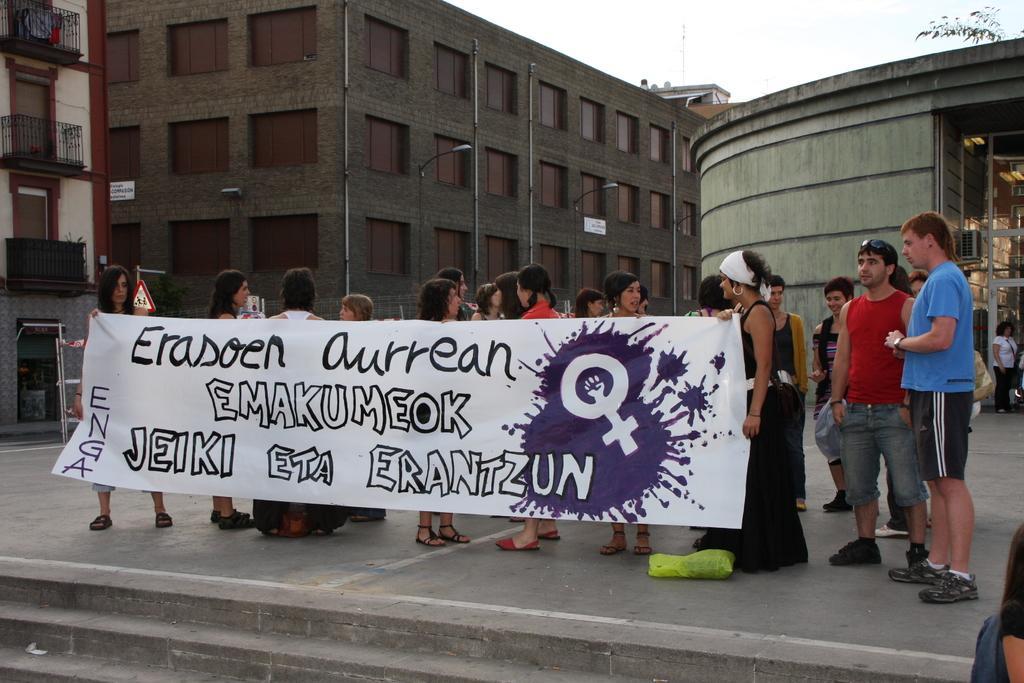Please provide a concise description of this image. In this image we can see people holding a banner. At the bottom there are stairs and we can see buildings. There are poles and we can see a tree. In the background there is sky. 